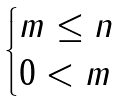Convert formula to latex. <formula><loc_0><loc_0><loc_500><loc_500>\begin{cases} m \leq n \\ 0 < m \end{cases}</formula> 